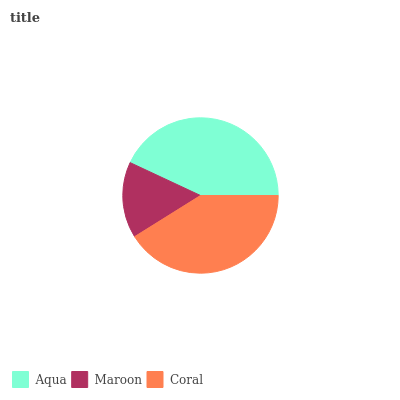Is Maroon the minimum?
Answer yes or no. Yes. Is Aqua the maximum?
Answer yes or no. Yes. Is Coral the minimum?
Answer yes or no. No. Is Coral the maximum?
Answer yes or no. No. Is Coral greater than Maroon?
Answer yes or no. Yes. Is Maroon less than Coral?
Answer yes or no. Yes. Is Maroon greater than Coral?
Answer yes or no. No. Is Coral less than Maroon?
Answer yes or no. No. Is Coral the high median?
Answer yes or no. Yes. Is Coral the low median?
Answer yes or no. Yes. Is Aqua the high median?
Answer yes or no. No. Is Aqua the low median?
Answer yes or no. No. 